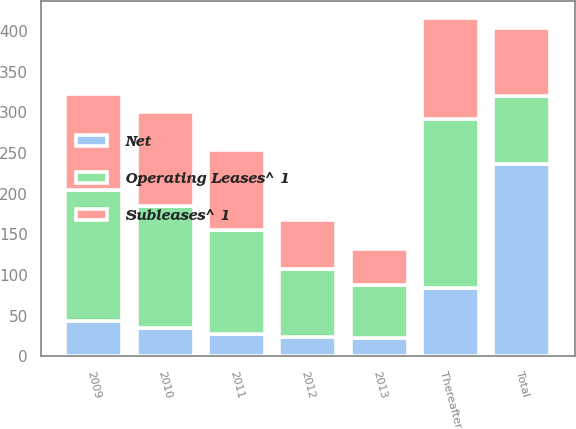Convert chart to OTSL. <chart><loc_0><loc_0><loc_500><loc_500><stacked_bar_chart><ecel><fcel>2009<fcel>2010<fcel>2011<fcel>2012<fcel>2013<fcel>Thereafter<fcel>Total<nl><fcel>Operating Leases^ 1<fcel>161<fcel>150<fcel>127<fcel>84<fcel>66<fcel>208<fcel>84<nl><fcel>Net<fcel>43<fcel>35<fcel>28<fcel>24<fcel>22<fcel>84<fcel>236<nl><fcel>Subleases^ 1<fcel>118<fcel>115<fcel>99<fcel>60<fcel>44<fcel>124<fcel>84<nl></chart> 